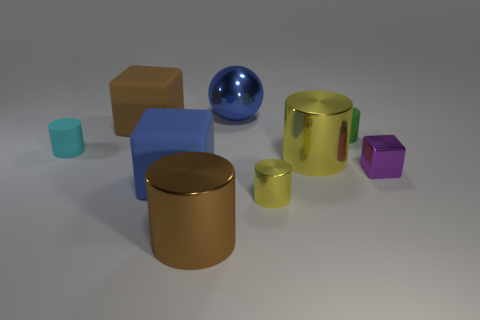What material is the green cylinder behind the yellow metallic object to the right of the tiny yellow cylinder made of?
Your answer should be very brief. Rubber. What number of objects are blocks that are in front of the small purple metal thing or blocks that are in front of the cyan rubber cylinder?
Give a very brief answer. 2. There is a green thing that is right of the yellow cylinder that is in front of the large blue object that is in front of the tiny metal block; what size is it?
Offer a terse response. Small. Are there an equal number of big yellow shiny cylinders behind the green matte thing and big purple metal cylinders?
Ensure brevity in your answer.  Yes. Is there anything else that is the same shape as the blue shiny thing?
Keep it short and to the point. No. Does the purple shiny thing have the same shape as the matte object in front of the small cyan cylinder?
Give a very brief answer. Yes. What size is the brown object that is the same shape as the small cyan rubber object?
Keep it short and to the point. Large. What number of other things are there of the same material as the tiny cube
Give a very brief answer. 4. What is the green cylinder made of?
Provide a succinct answer. Rubber. There is a large metallic cylinder that is behind the large brown cylinder; is it the same color as the tiny cylinder in front of the cyan rubber cylinder?
Provide a short and direct response. Yes. 